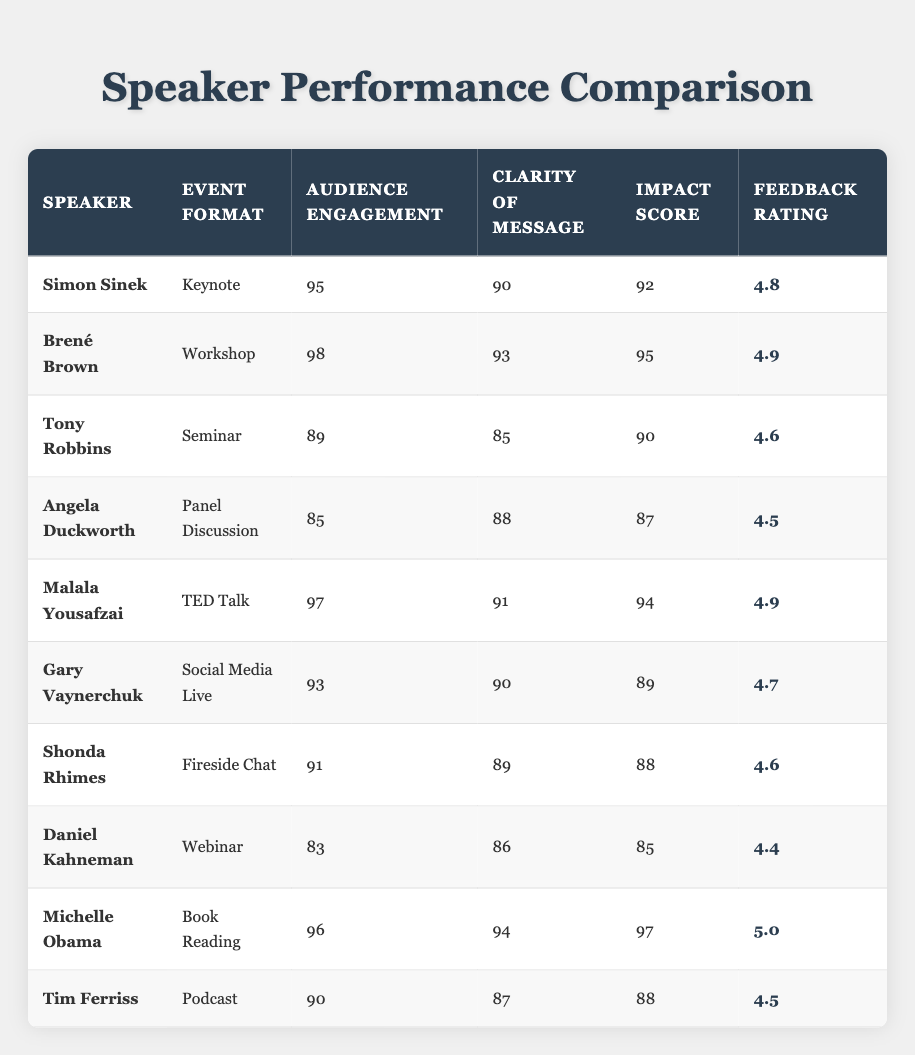What is the highest audience engagement score among the speakers? Looking at the "Audience Engagement" column, Brené Brown has the highest score at 98.
Answer: 98 Which speaker had a feedback rating of 5.0? Scanning the "Feedback Rating" column, it is clear that Michelle Obama received a rating of 5.0.
Answer: Michelle Obama What is the average clarity of message score for all speakers? To find the average clarity, sum the clarity scores (90 + 93 + 85 + 88 + 91 + 90 + 89 + 86 + 94 + 87) =  900, which divided by 10 (the number of speakers) equals 90.
Answer: 90 Did Simon Sinek receive a higher impact score than Tony Robbins? Simon Sinek's impact score is 92, while Tony Robbins' is 90; hence, Simon Sinek has a higher score.
Answer: Yes What is the total audience engagement score for all speakers participating in a workshop or a seminar? For workshops, Brené Brown has 98, and for seminars, Tony Robbins has 89. Adding these gives a total of 98 + 89 = 187.
Answer: 187 Which speaker performed the worst in terms of audience engagement and in which event format? By reviewing the scores, Daniel Kahneman has the lowest audience engagement score of 83, and he performed in a Webinar.
Answer: Daniel Kahneman, Webinar Which event format yielded the highest impact score? Reviewing the event formats, Michelle Obama achieved the highest impact score of 97 during a Book Reading.
Answer: Book Reading Is there any speaker who scored above 90 in both audience engagement and clarity of message? Yes, both Brené Brown (98 and 93) and Michelle Obama (96 and 94) scored above 90 in both categories.
Answer: Yes What is the difference between the highest and lowest feedback ratings? The highest feedback rating is 5.0 (Michelle Obama) and the lowest is 4.4 (Daniel Kahneman). The difference is 5.0 - 4.4 = 0.6.
Answer: 0.6 How many speakers had audience engagement scores over 90? Counting the scores in the table, five speakers (Simon Sinek, Brené Brown, Malala Yousafzai, Gary Vaynerchuk, and Michelle Obama) had scores over 90.
Answer: 5 